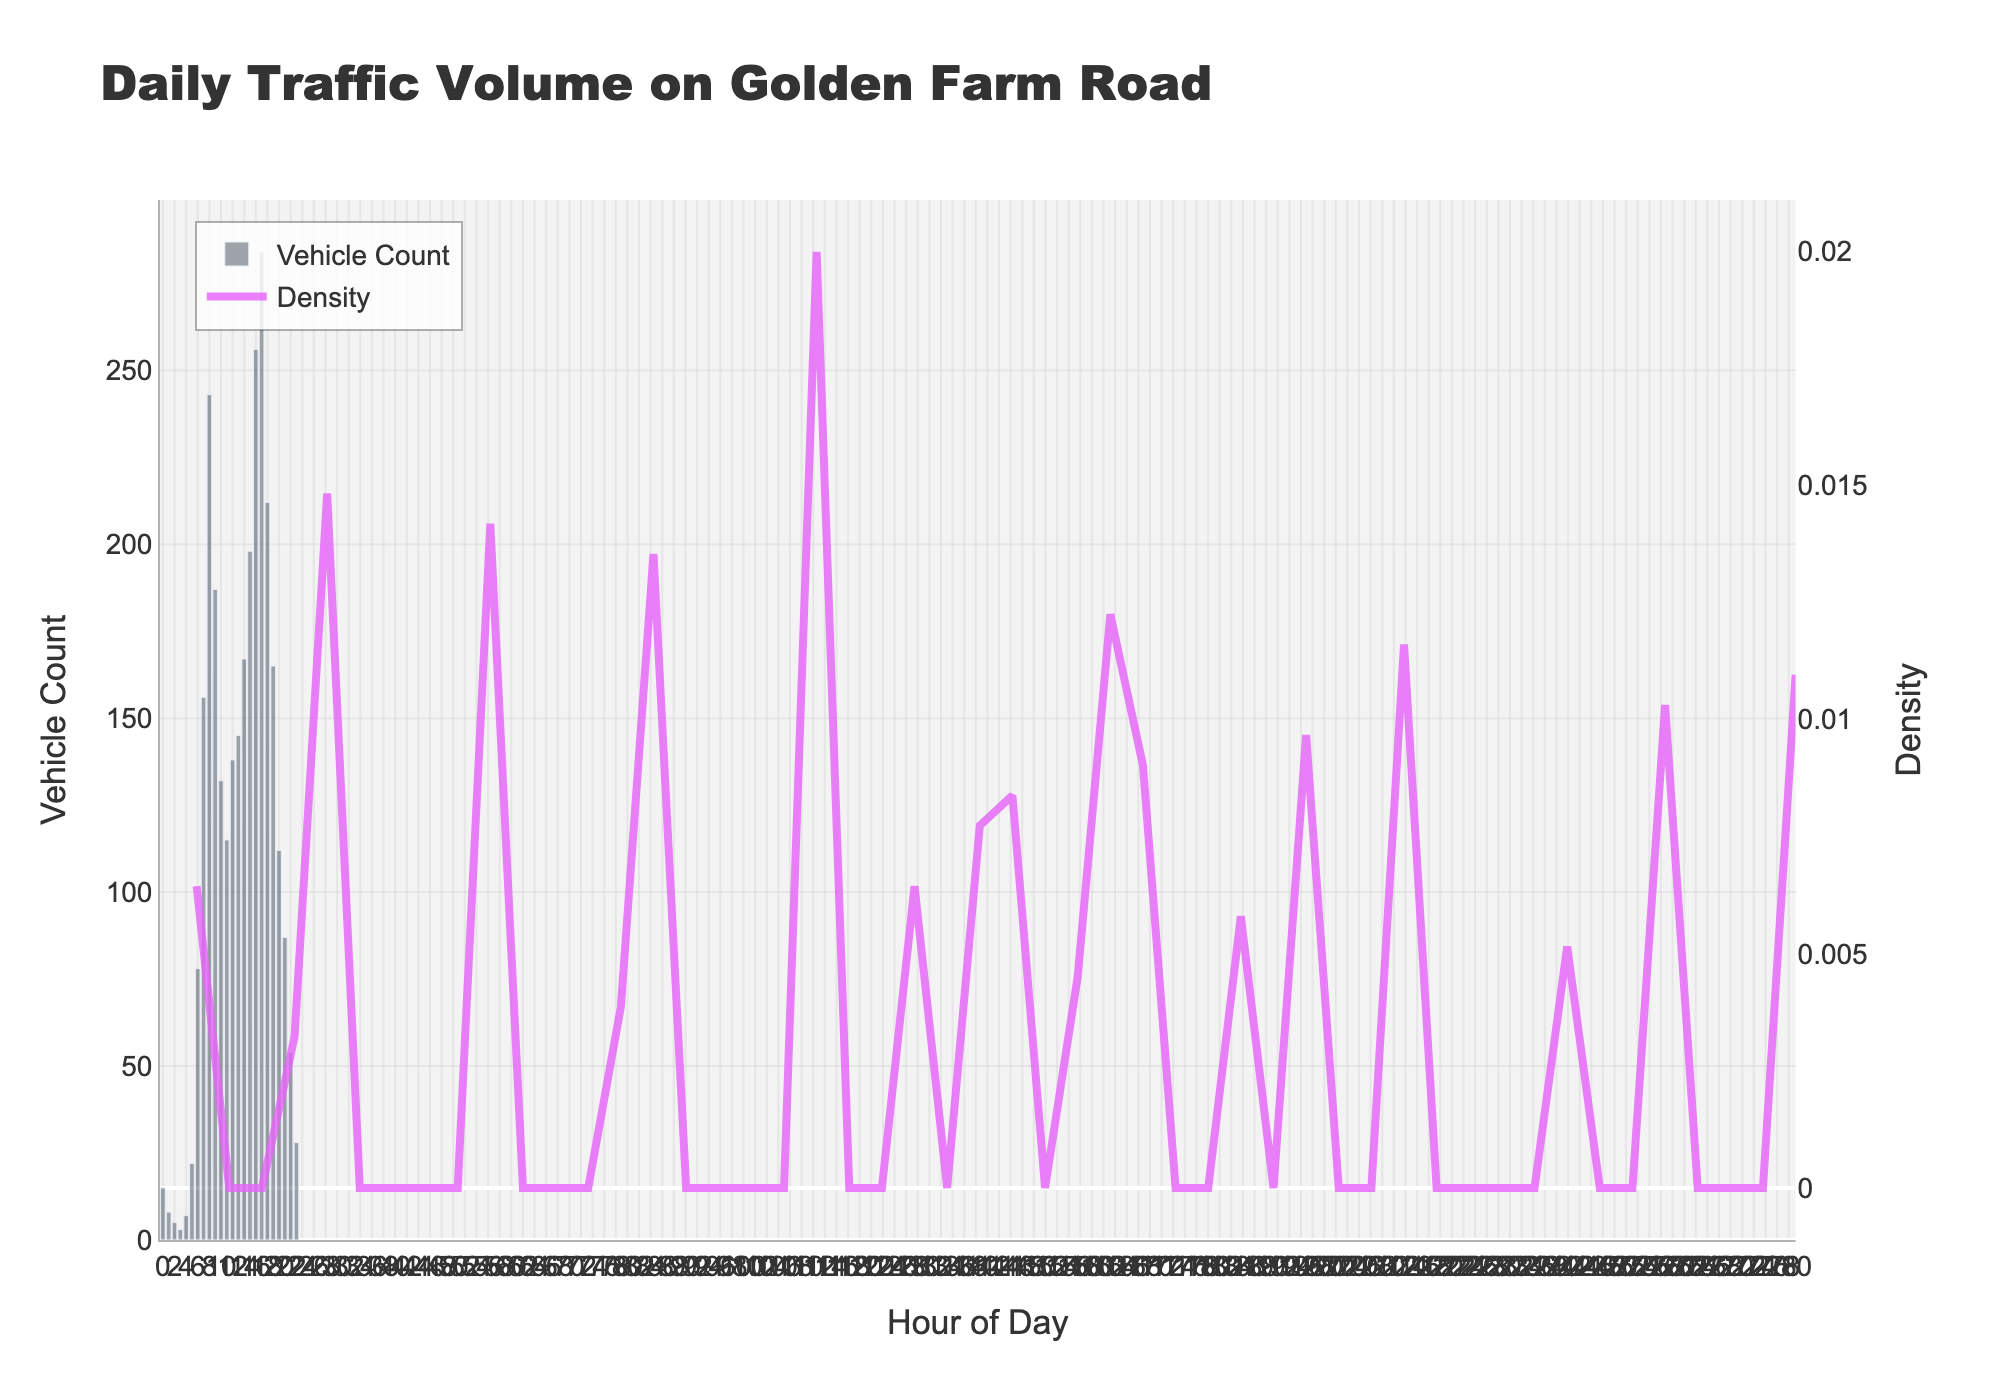What is the title of the graph? The title of the graph is usually prominently displayed at the top. In this case, it reads 'Daily Traffic Volume on Golden Farm Road'.
Answer: Daily Traffic Volume on Golden Farm Road At what hour does the traffic volume start to significantly increase? To find when traffic volume increases, look for the transition from low to high vehicle counts. Traffic volume starts noticeably increasing around 5 a.m. onwards.
Answer: 5 a.m Which hour of the day has the highest vehicle count? The height of the bars represents the vehicle count. The tallest bar corresponds to the hour with the highest traffic. The highest vehicle count occurs at 5 p.m. (17:00).
Answer: 5 p.m When does the traffic density curve peak? The KDE (density curve) peaks where it reaches the highest point. According to the graph, this peak occurs around 5 p.m.
Answer: 5 p.m What is the vehicle count at 2 a.m.? The vehicle count at each hour is indicated by the height of the corresponding bar. At 2 a.m., the count is 5 vehicles.
Answer: 5 During what hours is the traffic volume above 200 vehicles? Count the bars that extend above the 200-vehicle mark. The traffic volume exceeds 200 vehicles between 8 a.m. to 9 a.m. and from 3 p.m. to 6 p.m.
Answer: 8–9 a.m., 3–6 p.m How does the vehicle count at 9 a.m. compare to 8 a.m.? Compare the heights of the bars at 9 a.m. and 8 a.m. The vehicle count at 9 a.m. (187) is lower than at 8 a.m. (243).
Answer: Lower What are the off-peak traffic hours? Off-peak hours are when the vehicle count is relatively low. These occur late at night and early in the morning, specifically from 10 p.m. to 4 a.m.
Answer: 10 p.m. to 4 a.m What is the average vehicle count between 3 p.m. and 5 p.m.? Sum the vehicle counts for 3 p.m., 4 p.m., and 5 p.m. and divide by three: (198 + 256 + 284) / 3 = 246
Answer: 246 Which hour has the lowest traffic volume? The shortest bar in the histogram indicates the hour with the lowest traffic. This occurs at 3 a.m. with a vehicle count of 3.
Answer: 3 a.m 